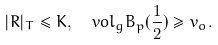Convert formula to latex. <formula><loc_0><loc_0><loc_500><loc_500>| { R } | _ { T } \leq K , \ \ v o l _ { g } B _ { p } ( \frac { 1 } { 2 } ) \geq v _ { o } .</formula> 